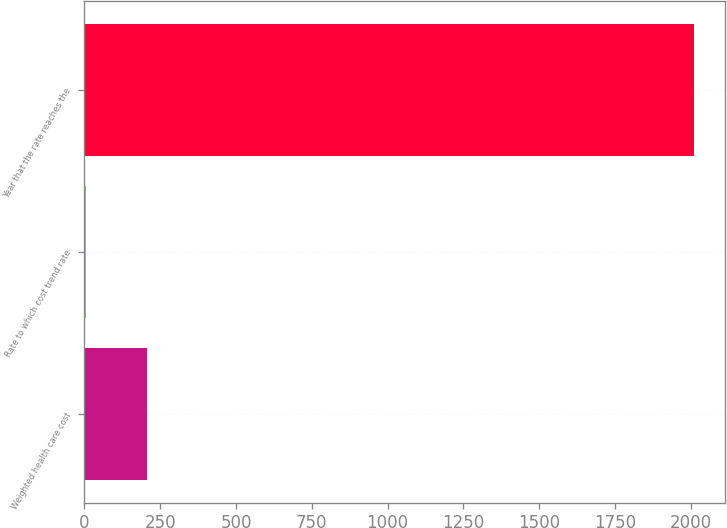<chart> <loc_0><loc_0><loc_500><loc_500><bar_chart><fcel>Weighted health care cost<fcel>Rate to which cost trend rate<fcel>Year that the rate reaches the<nl><fcel>205.7<fcel>5<fcel>2012<nl></chart> 